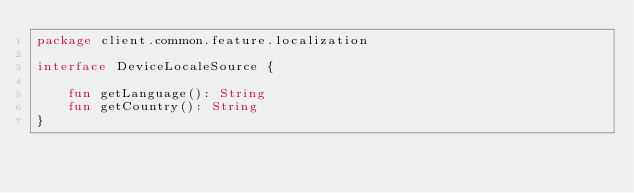Convert code to text. <code><loc_0><loc_0><loc_500><loc_500><_Kotlin_>package client.common.feature.localization

interface DeviceLocaleSource {

    fun getLanguage(): String
    fun getCountry(): String
}</code> 